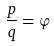<formula> <loc_0><loc_0><loc_500><loc_500>\frac { p } { q } = \varphi</formula> 